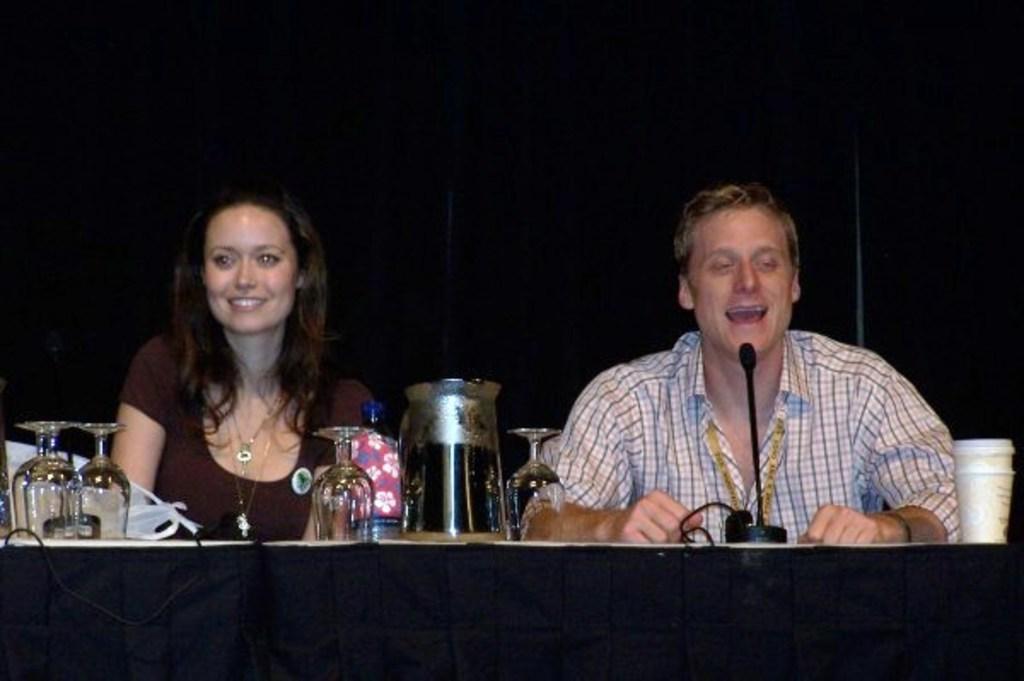Describe this image in one or two sentences. In the image there is a man and woman sitting behind table with wine glasses,jar and mic on it and behind them there is black wall. 